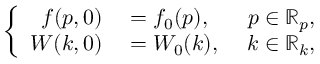<formula> <loc_0><loc_0><loc_500><loc_500>\left \{ \begin{array} { r l r } { f ( p , 0 ) } & = f _ { 0 } ( p ) , \ } & { p \in \mathbb { R } _ { p } , } \\ { W ( k , 0 ) } & = W _ { 0 } ( k ) , \ } & { k \in \mathbb { R } _ { k } , } \end{array}</formula> 